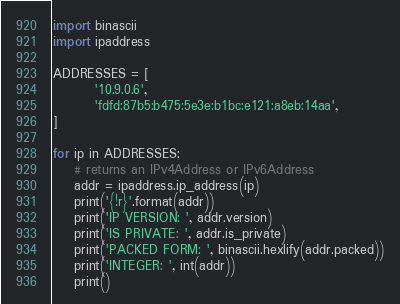<code> <loc_0><loc_0><loc_500><loc_500><_Python_>import binascii
import ipaddress

ADDRESSES = [
        '10.9.0.6',
        'fdfd:87b5:b475:5e3e:b1bc:e121:a8eb:14aa',
]

for ip in ADDRESSES:
    # returns an IPv4Address or IPv6Address
    addr = ipaddress.ip_address(ip)
    print('{!r}'.format(addr))
    print('IP VERSION: ', addr.version)
    print('IS PRIVATE: ', addr.is_private)
    print('PACKED FORM: ', binascii.hexlify(addr.packed))
    print('INTEGER: ', int(addr))
    print()

</code> 